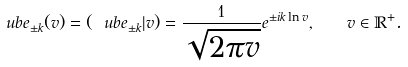<formula> <loc_0><loc_0><loc_500><loc_500>\ u b { e } _ { \pm k } ( v ) = ( \ u b { e } _ { \pm k } | v ) = \frac { 1 } { \sqrt { 2 \pi v } } e ^ { \pm i k \ln v } , \quad v \in \mathbb { R } ^ { + } .</formula> 